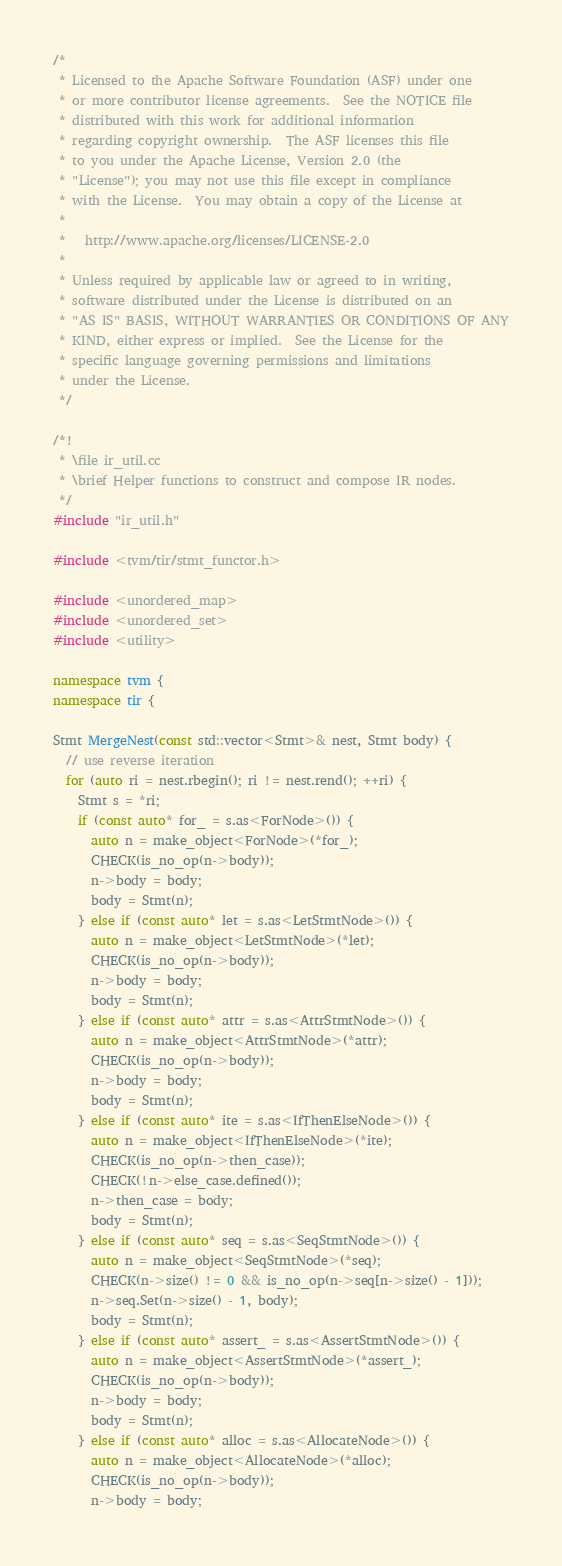Convert code to text. <code><loc_0><loc_0><loc_500><loc_500><_C++_>/*
 * Licensed to the Apache Software Foundation (ASF) under one
 * or more contributor license agreements.  See the NOTICE file
 * distributed with this work for additional information
 * regarding copyright ownership.  The ASF licenses this file
 * to you under the Apache License, Version 2.0 (the
 * "License"); you may not use this file except in compliance
 * with the License.  You may obtain a copy of the License at
 *
 *   http://www.apache.org/licenses/LICENSE-2.0
 *
 * Unless required by applicable law or agreed to in writing,
 * software distributed under the License is distributed on an
 * "AS IS" BASIS, WITHOUT WARRANTIES OR CONDITIONS OF ANY
 * KIND, either express or implied.  See the License for the
 * specific language governing permissions and limitations
 * under the License.
 */

/*!
 * \file ir_util.cc
 * \brief Helper functions to construct and compose IR nodes.
 */
#include "ir_util.h"

#include <tvm/tir/stmt_functor.h>

#include <unordered_map>
#include <unordered_set>
#include <utility>

namespace tvm {
namespace tir {

Stmt MergeNest(const std::vector<Stmt>& nest, Stmt body) {
  // use reverse iteration
  for (auto ri = nest.rbegin(); ri != nest.rend(); ++ri) {
    Stmt s = *ri;
    if (const auto* for_ = s.as<ForNode>()) {
      auto n = make_object<ForNode>(*for_);
      CHECK(is_no_op(n->body));
      n->body = body;
      body = Stmt(n);
    } else if (const auto* let = s.as<LetStmtNode>()) {
      auto n = make_object<LetStmtNode>(*let);
      CHECK(is_no_op(n->body));
      n->body = body;
      body = Stmt(n);
    } else if (const auto* attr = s.as<AttrStmtNode>()) {
      auto n = make_object<AttrStmtNode>(*attr);
      CHECK(is_no_op(n->body));
      n->body = body;
      body = Stmt(n);
    } else if (const auto* ite = s.as<IfThenElseNode>()) {
      auto n = make_object<IfThenElseNode>(*ite);
      CHECK(is_no_op(n->then_case));
      CHECK(!n->else_case.defined());
      n->then_case = body;
      body = Stmt(n);
    } else if (const auto* seq = s.as<SeqStmtNode>()) {
      auto n = make_object<SeqStmtNode>(*seq);
      CHECK(n->size() != 0 && is_no_op(n->seq[n->size() - 1]));
      n->seq.Set(n->size() - 1, body);
      body = Stmt(n);
    } else if (const auto* assert_ = s.as<AssertStmtNode>()) {
      auto n = make_object<AssertStmtNode>(*assert_);
      CHECK(is_no_op(n->body));
      n->body = body;
      body = Stmt(n);
    } else if (const auto* alloc = s.as<AllocateNode>()) {
      auto n = make_object<AllocateNode>(*alloc);
      CHECK(is_no_op(n->body));
      n->body = body;</code> 